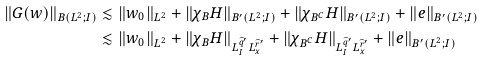<formula> <loc_0><loc_0><loc_500><loc_500>\| G ( w ) \| _ { B ( L ^ { 2 } ; I ) } & \lesssim \| w _ { 0 } \| _ { L ^ { 2 } } + \| \chi _ { B } H \| _ { B ^ { \prime } ( L ^ { 2 } ; I ) } + \| \chi _ { B ^ { C } } H \| _ { B ^ { \prime } ( L ^ { 2 } ; I ) } + \| e \| _ { B ^ { \prime } ( L ^ { 2 } ; I ) } \\ & \lesssim \| w _ { 0 } \| _ { L ^ { 2 } } + \| \chi _ { B } H \| _ { L _ { I } ^ { \widehat { q } ^ { \prime } } L _ { x } ^ { \widehat { r } ^ { \prime } } } + \| \chi _ { B ^ { C } } H \| _ { L _ { I } ^ { \widehat { q } ^ { \prime } } L _ { x } ^ { \widehat { r } ^ { \prime } } } + \| e \| _ { B ^ { \prime } ( L ^ { 2 } ; I ) }</formula> 